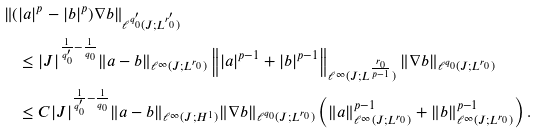Convert formula to latex. <formula><loc_0><loc_0><loc_500><loc_500>& \left \| ( | a | ^ { p } - | b | ^ { p } ) \nabla b \right \| _ { \ell ^ { q _ { 0 } ^ { \prime } } ( J ; L ^ { r _ { 0 } ^ { \prime } } ) } \\ & \quad \leq | J | ^ { \frac { 1 } { q _ { 0 } ^ { \prime } } - \frac { 1 } { q _ { 0 } } } \| a - b \| _ { \ell ^ { \infty } ( J ; L ^ { r _ { 0 } } ) } \left \| | a | ^ { p - 1 } + | b | ^ { p - 1 } \right \| _ { \ell ^ { \infty } ( J ; L ^ { \frac { r _ { 0 } } { p - 1 } } ) } \| \nabla b \| _ { \ell ^ { q _ { 0 } } ( J ; L ^ { r _ { 0 } } ) } \\ & \quad \leq C | J | ^ { \frac { 1 } { q _ { 0 } ^ { \prime } } - \frac { 1 } { q _ { 0 } } } \| a - b \| _ { \ell ^ { \infty } ( J ; H ^ { 1 } ) } \| \nabla b \| _ { \ell ^ { q _ { 0 } } ( J ; L ^ { r _ { 0 } } ) } \left ( \| a \| _ { \ell ^ { \infty } ( J ; L ^ { r _ { 0 } } ) } ^ { p - 1 } + \| b \| _ { \ell ^ { \infty } ( J ; L ^ { r _ { 0 } } ) } ^ { p - 1 } \right ) .</formula> 